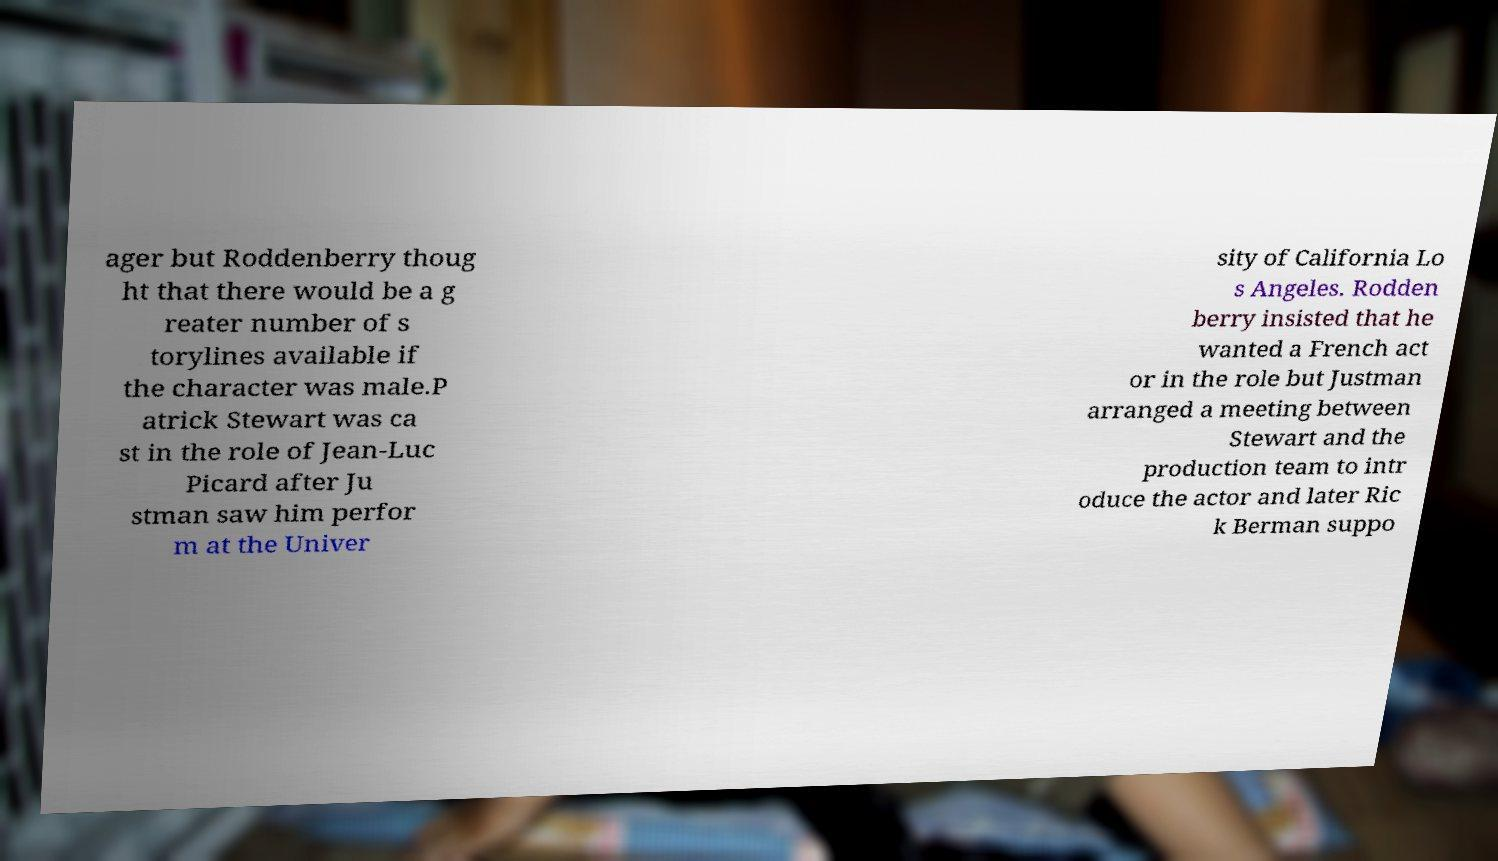What messages or text are displayed in this image? I need them in a readable, typed format. ager but Roddenberry thoug ht that there would be a g reater number of s torylines available if the character was male.P atrick Stewart was ca st in the role of Jean-Luc Picard after Ju stman saw him perfor m at the Univer sity of California Lo s Angeles. Rodden berry insisted that he wanted a French act or in the role but Justman arranged a meeting between Stewart and the production team to intr oduce the actor and later Ric k Berman suppo 